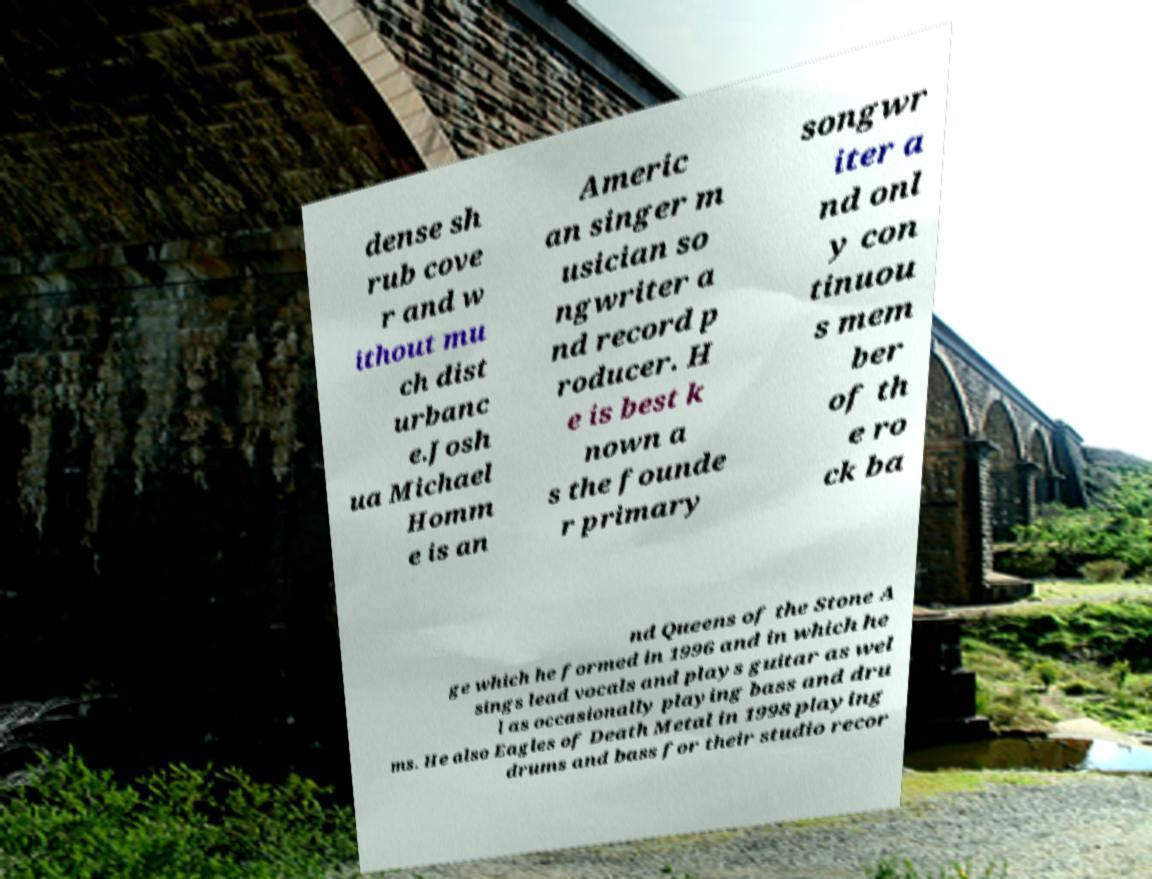Can you read and provide the text displayed in the image?This photo seems to have some interesting text. Can you extract and type it out for me? dense sh rub cove r and w ithout mu ch dist urbanc e.Josh ua Michael Homm e is an Americ an singer m usician so ngwriter a nd record p roducer. H e is best k nown a s the founde r primary songwr iter a nd onl y con tinuou s mem ber of th e ro ck ba nd Queens of the Stone A ge which he formed in 1996 and in which he sings lead vocals and plays guitar as wel l as occasionally playing bass and dru ms. He also Eagles of Death Metal in 1998 playing drums and bass for their studio recor 